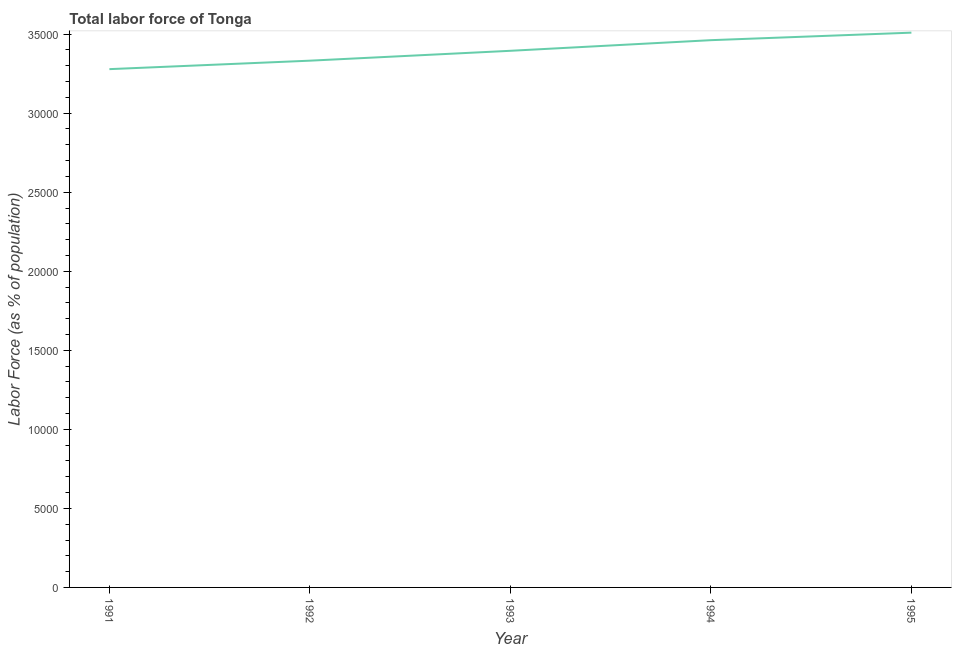What is the total labor force in 1991?
Make the answer very short. 3.28e+04. Across all years, what is the maximum total labor force?
Keep it short and to the point. 3.51e+04. Across all years, what is the minimum total labor force?
Provide a succinct answer. 3.28e+04. What is the sum of the total labor force?
Provide a short and direct response. 1.70e+05. What is the difference between the total labor force in 1993 and 1994?
Keep it short and to the point. -672. What is the average total labor force per year?
Provide a short and direct response. 3.40e+04. What is the median total labor force?
Make the answer very short. 3.39e+04. In how many years, is the total labor force greater than 19000 %?
Offer a very short reply. 5. Do a majority of the years between 1995 and 1992 (inclusive) have total labor force greater than 29000 %?
Your answer should be compact. Yes. What is the ratio of the total labor force in 1992 to that in 1994?
Your answer should be very brief. 0.96. What is the difference between the highest and the second highest total labor force?
Offer a terse response. 476. Is the sum of the total labor force in 1991 and 1992 greater than the maximum total labor force across all years?
Give a very brief answer. Yes. What is the difference between the highest and the lowest total labor force?
Ensure brevity in your answer.  2308. In how many years, is the total labor force greater than the average total labor force taken over all years?
Ensure brevity in your answer.  2. Does the total labor force monotonically increase over the years?
Your answer should be very brief. Yes. How many lines are there?
Provide a succinct answer. 1. How many years are there in the graph?
Offer a terse response. 5. What is the difference between two consecutive major ticks on the Y-axis?
Make the answer very short. 5000. Does the graph contain any zero values?
Your response must be concise. No. Does the graph contain grids?
Your answer should be compact. No. What is the title of the graph?
Your answer should be very brief. Total labor force of Tonga. What is the label or title of the X-axis?
Your answer should be compact. Year. What is the label or title of the Y-axis?
Provide a short and direct response. Labor Force (as % of population). What is the Labor Force (as % of population) in 1991?
Give a very brief answer. 3.28e+04. What is the Labor Force (as % of population) in 1992?
Your answer should be compact. 3.33e+04. What is the Labor Force (as % of population) of 1993?
Keep it short and to the point. 3.39e+04. What is the Labor Force (as % of population) of 1994?
Provide a short and direct response. 3.46e+04. What is the Labor Force (as % of population) in 1995?
Offer a terse response. 3.51e+04. What is the difference between the Labor Force (as % of population) in 1991 and 1992?
Offer a very short reply. -535. What is the difference between the Labor Force (as % of population) in 1991 and 1993?
Your response must be concise. -1160. What is the difference between the Labor Force (as % of population) in 1991 and 1994?
Give a very brief answer. -1832. What is the difference between the Labor Force (as % of population) in 1991 and 1995?
Provide a short and direct response. -2308. What is the difference between the Labor Force (as % of population) in 1992 and 1993?
Your answer should be compact. -625. What is the difference between the Labor Force (as % of population) in 1992 and 1994?
Ensure brevity in your answer.  -1297. What is the difference between the Labor Force (as % of population) in 1992 and 1995?
Offer a terse response. -1773. What is the difference between the Labor Force (as % of population) in 1993 and 1994?
Your answer should be compact. -672. What is the difference between the Labor Force (as % of population) in 1993 and 1995?
Give a very brief answer. -1148. What is the difference between the Labor Force (as % of population) in 1994 and 1995?
Give a very brief answer. -476. What is the ratio of the Labor Force (as % of population) in 1991 to that in 1992?
Your response must be concise. 0.98. What is the ratio of the Labor Force (as % of population) in 1991 to that in 1994?
Give a very brief answer. 0.95. What is the ratio of the Labor Force (as % of population) in 1991 to that in 1995?
Your answer should be compact. 0.93. What is the ratio of the Labor Force (as % of population) in 1992 to that in 1994?
Make the answer very short. 0.96. What is the ratio of the Labor Force (as % of population) in 1992 to that in 1995?
Offer a terse response. 0.95. What is the ratio of the Labor Force (as % of population) in 1993 to that in 1995?
Your answer should be very brief. 0.97. 